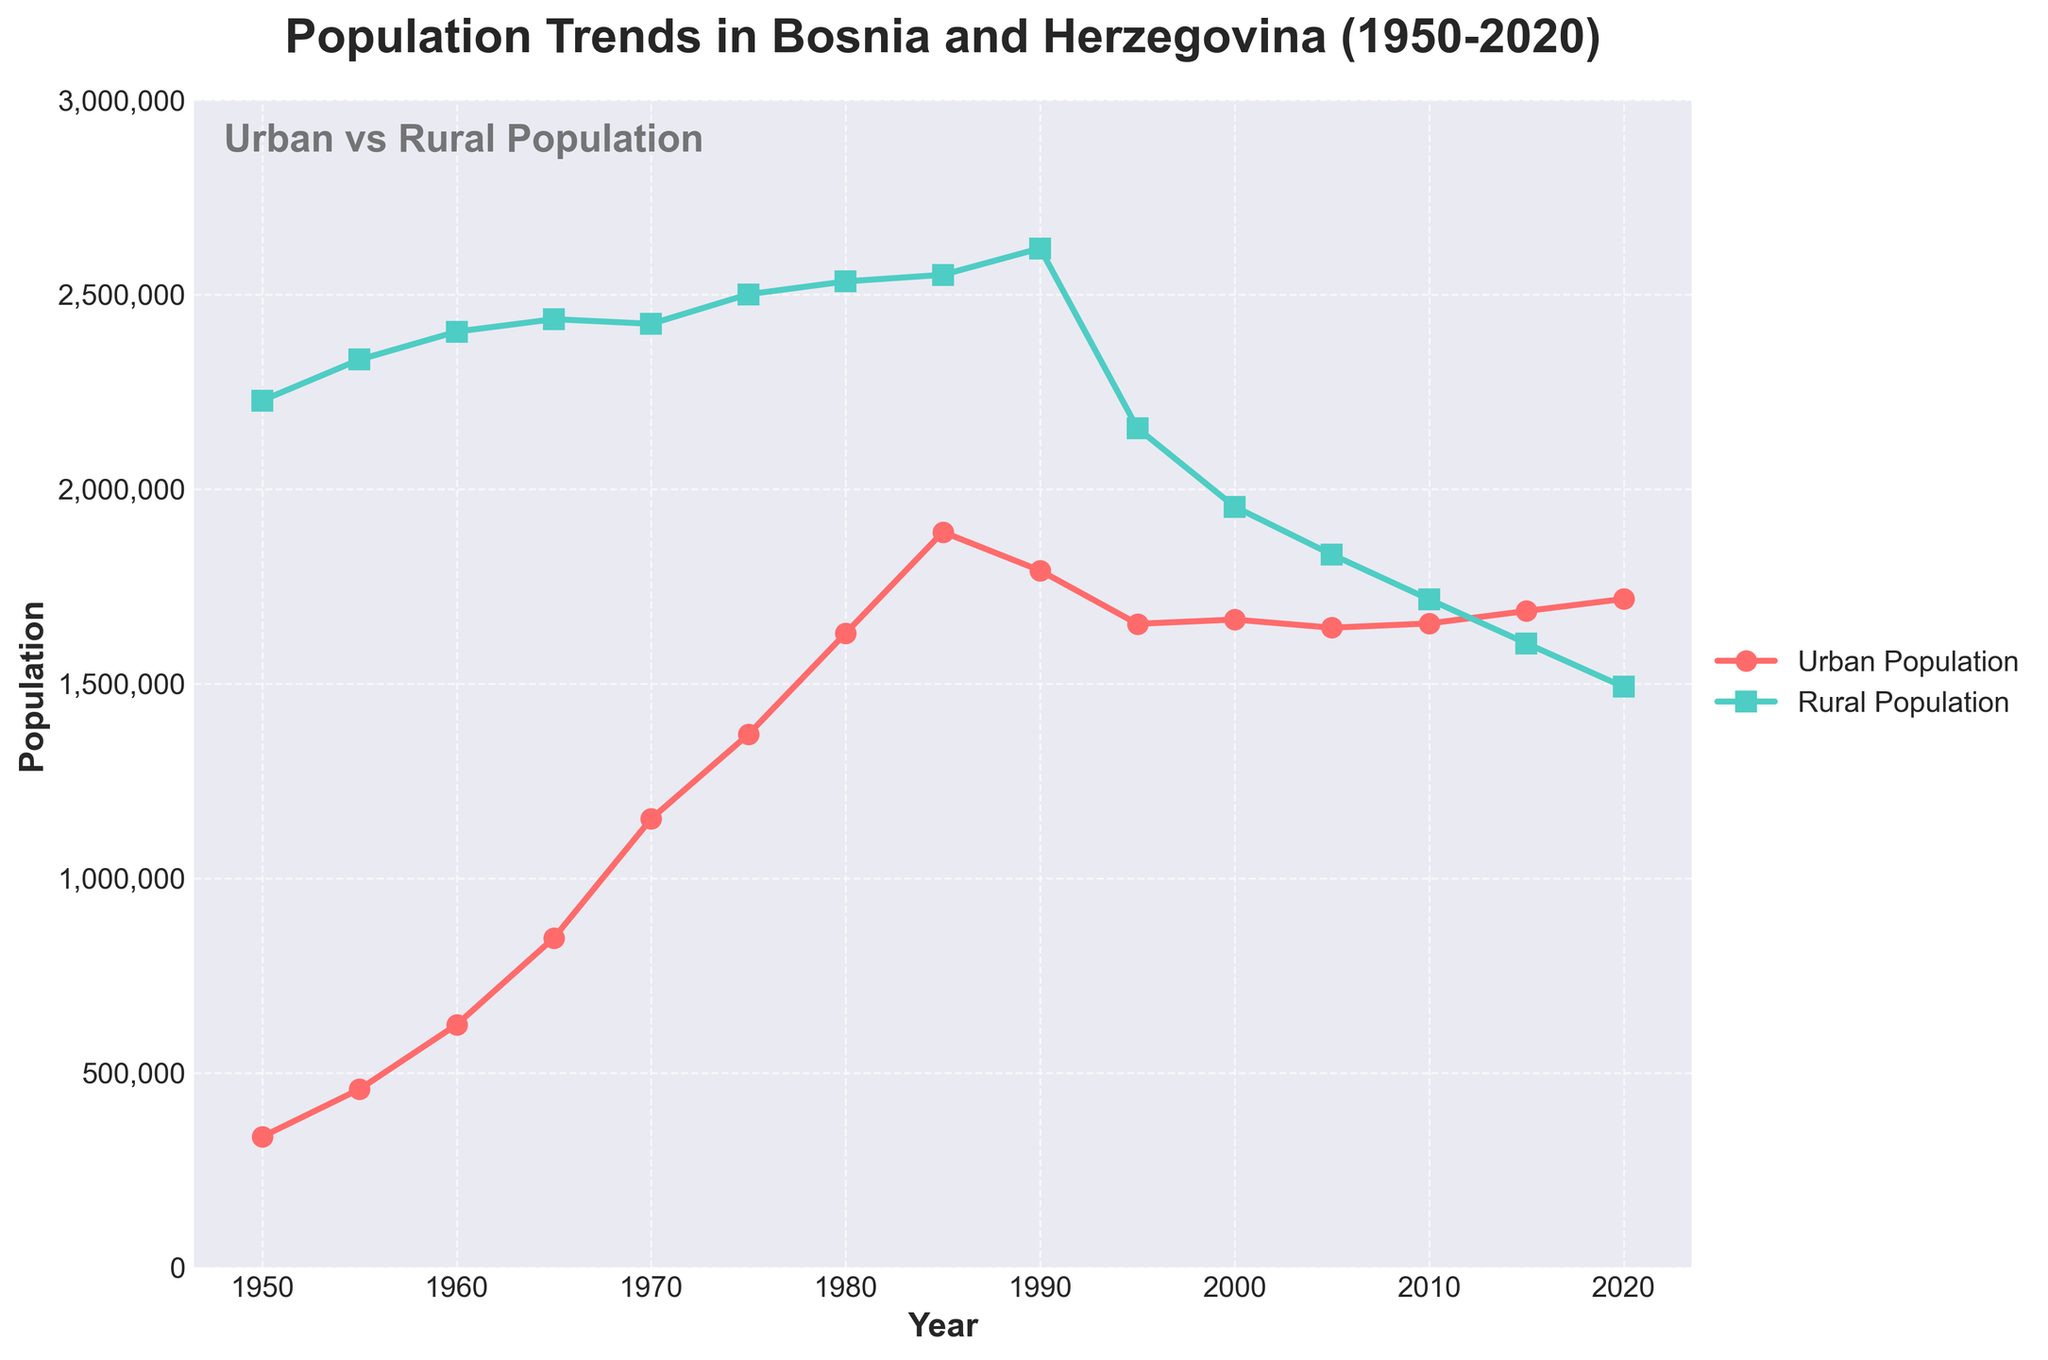What general trend do you observe in the urban population from 1950 to 2020? The urban population in Bosnia and Herzegovina shows a clear increasing trend from 1950 to 2020, with some minor fluctuations. The population grows steadily, particularly after 1950, reaching its peak in 2020.
Answer: Increasing trend During which decade did the rural population peak? By examining the rural population data points, we see that the rural population peaked during the decade from 1980 to 1990 with the highest value recorded in 1990.
Answer: 1980-1990 Which year shows the largest gap between the urban and rural populations? By comparing the differences between the urban and rural populations year by year, the largest gap occurs in 1950 where the rural population (2,228,000) far exceeds the urban population (336,000) by 1,892,000.
Answer: 1950 How does the urban population in 1980 compare to the rural population in 2020? The urban population in 1980 is 1,630,000, while the rural population in 2020 is 1,492,000. Comparing these values, the urban population in 1980 is slightly higher than the rural population in 2020.
Answer: Urban population in 1980 is greater What was the percentage increase in the urban population from 1950 to 2020? Start with the urban population in 1950 (336,000) and 2020 (1,718,000). Find the increase which is 1,718,000 - 336,000 = 1,382,000. Calculate the percentage increase: (1,382,000 / 336,000) * 100 ≈ 411.31%.
Answer: Approximately 411.31% Which period shows a significant reduction in the rural population? From 1990 to 1995, the rural population drops from 2,619,000 to 2,157,000, a decrease of 462,000, indicating a significant reduction.
Answer: 1990-1995 What is the average rural population from 1950 to 2020? Add the rural populations from all years and divide by the number of years (15). Sum: 2,228,000 + 2,333,000 + 2,405,000 + 2,437,000 + 2,425,000 + 2,501,000 + 2,534,000 + 2,551,000 + 2,619,000 + 2,157,000 + 1,955,000 + 1,832,000 + 1,717,000 + 1,604,000 + 1,492,000 = 32,786,000. Average: 32,786,000 / 15 ≈ 2,185,733.33.
Answer: Approximately 2,185,733 In which periods did the rural population increase, and by how much? Look for periods where the rural population increased from one year to the next. Increases occur from 1950 to 1955 (105,000), 1955 to 1960 (72,000), 1970 to 1975 (76,000), 1975 to 1980 (33,000), 1980 to 1985 (17,000), and 1985 to 1990 (68,000). Sum these increases: 105,000 + 72,000 + 76,000 + 33,000 + 17,000 + 68,000 = 371,000.
Answer: Six periods, total increase 371,000 What's the trend for the sum of urban and rural populations from 1990 to 2020? Calculate the sum of urban and rural populations for 1990 (4,410,000), 1995 (3,811,000), 2000 (3,620,000), 2005 (3,476,000), 2010 (3,372,000), 2015 (3,291,000), and 2020 (3,210,000). There is a clear decreasing trend from 1990 to 2020.
Answer: Decreasing trend 